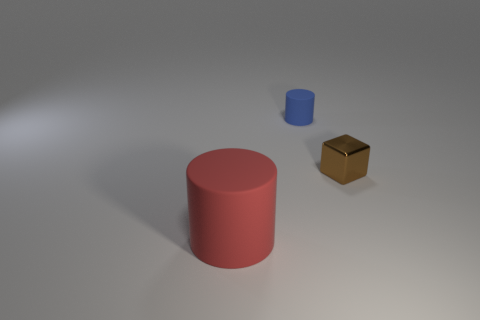Add 2 blue matte cubes. How many objects exist? 5 Subtract all cylinders. How many objects are left? 1 Add 1 metallic objects. How many metallic objects exist? 2 Subtract 0 yellow spheres. How many objects are left? 3 Subtract all small matte cylinders. Subtract all small metallic cubes. How many objects are left? 1 Add 1 brown metallic blocks. How many brown metallic blocks are left? 2 